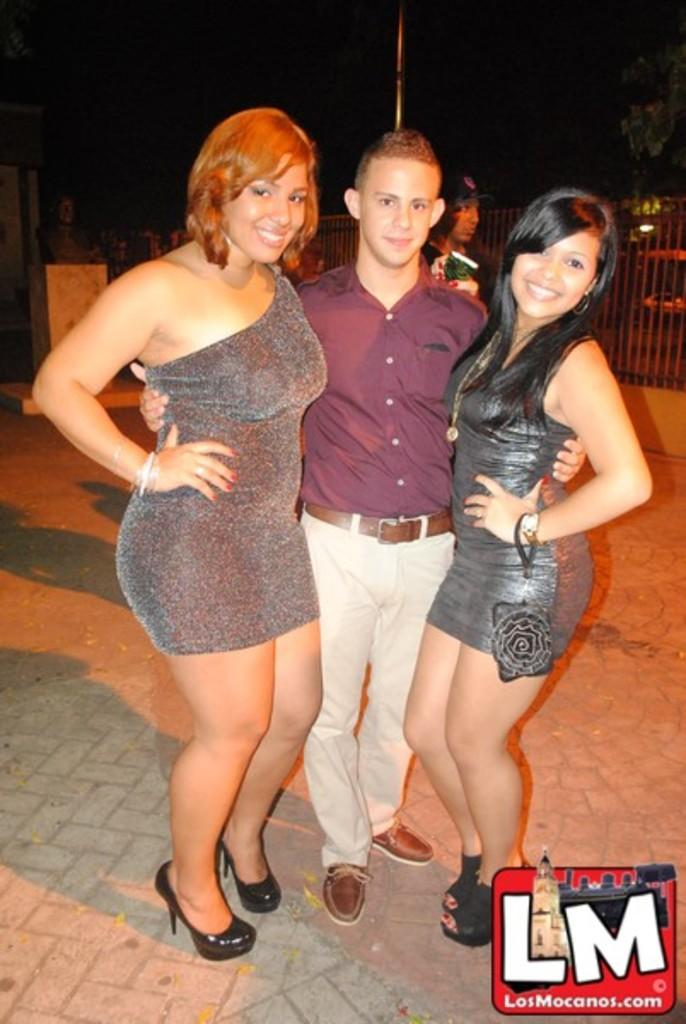What are the people in the image doing? The people in the image are standing on the ground. What can be seen in the background of the image? There is a fence and the sky visible in the background of the image. What type of dog is playing with the people in the image? There is no dog present in the image; the people are simply standing on the ground. 